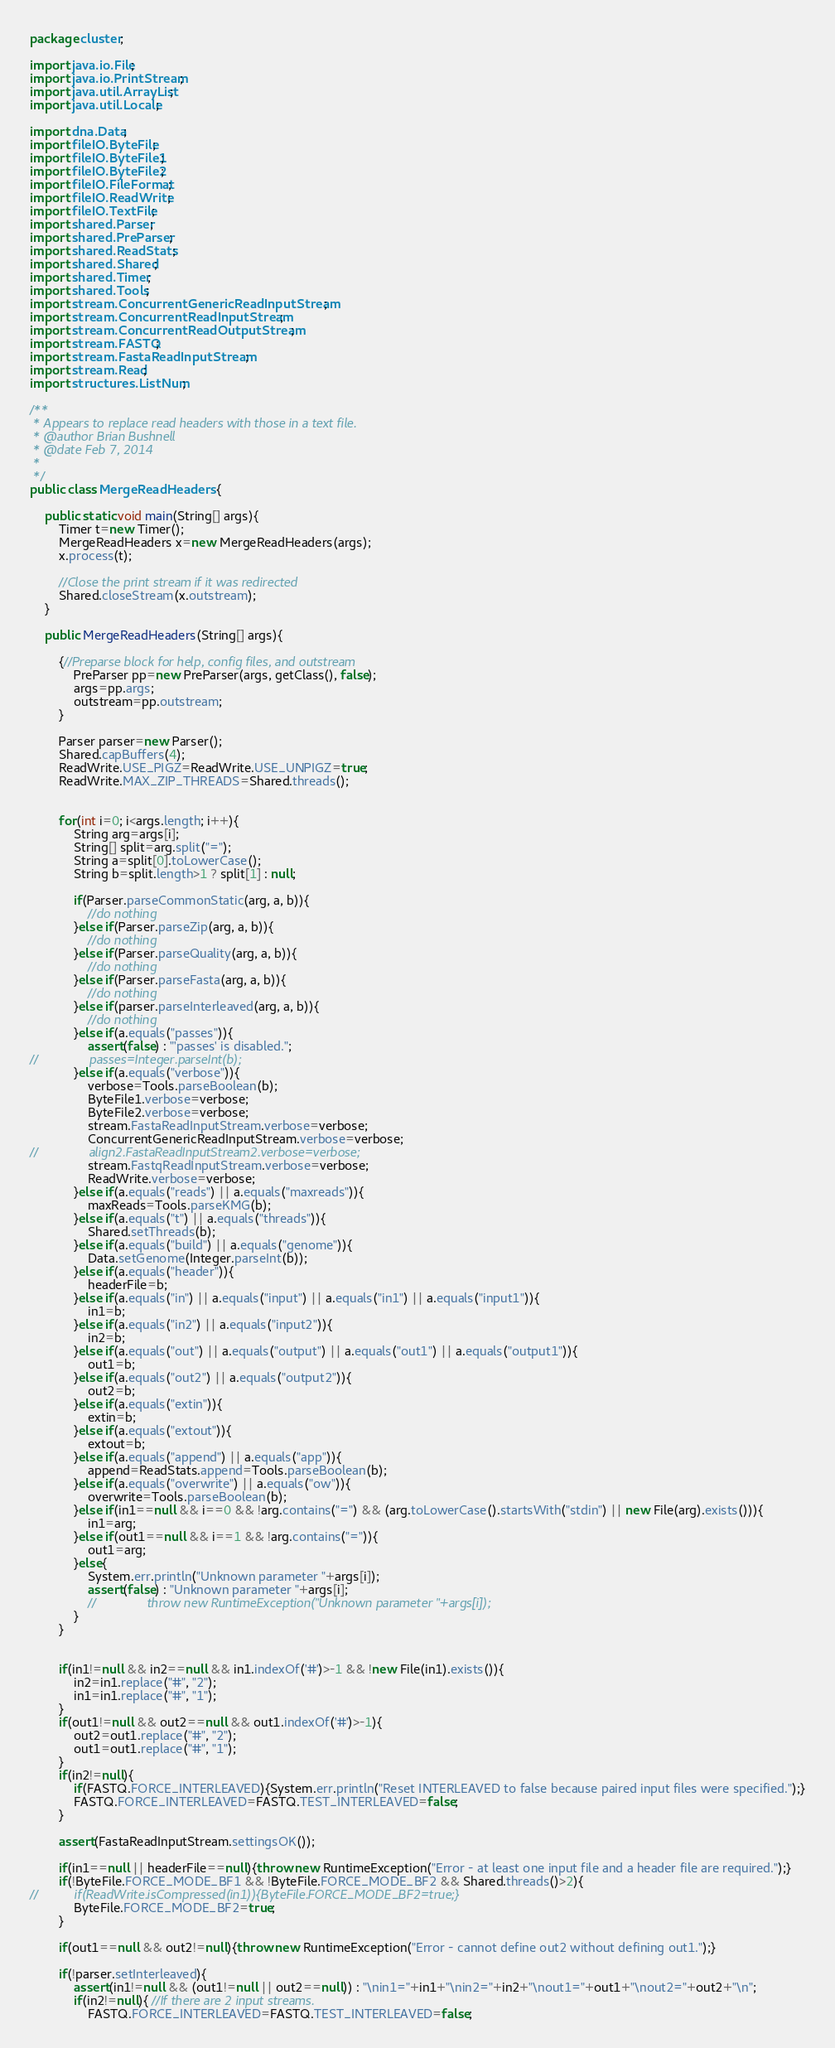<code> <loc_0><loc_0><loc_500><loc_500><_Java_>package cluster;

import java.io.File;
import java.io.PrintStream;
import java.util.ArrayList;
import java.util.Locale;

import dna.Data;
import fileIO.ByteFile;
import fileIO.ByteFile1;
import fileIO.ByteFile2;
import fileIO.FileFormat;
import fileIO.ReadWrite;
import fileIO.TextFile;
import shared.Parser;
import shared.PreParser;
import shared.ReadStats;
import shared.Shared;
import shared.Timer;
import shared.Tools;
import stream.ConcurrentGenericReadInputStream;
import stream.ConcurrentReadInputStream;
import stream.ConcurrentReadOutputStream;
import stream.FASTQ;
import stream.FastaReadInputStream;
import stream.Read;
import structures.ListNum;

/**
 * Appears to replace read headers with those in a text file.
 * @author Brian Bushnell
 * @date Feb 7, 2014
 *
 */
public class MergeReadHeaders {
	
	public static void main(String[] args){
		Timer t=new Timer();
		MergeReadHeaders x=new MergeReadHeaders(args);
		x.process(t);
		
		//Close the print stream if it was redirected
		Shared.closeStream(x.outstream);
	}
	
	public MergeReadHeaders(String[] args){
		
		{//Preparse block for help, config files, and outstream
			PreParser pp=new PreParser(args, getClass(), false);
			args=pp.args;
			outstream=pp.outstream;
		}
		
		Parser parser=new Parser();
		Shared.capBuffers(4);
		ReadWrite.USE_PIGZ=ReadWrite.USE_UNPIGZ=true;
		ReadWrite.MAX_ZIP_THREADS=Shared.threads();
		
		
		for(int i=0; i<args.length; i++){
			String arg=args[i];
			String[] split=arg.split("=");
			String a=split[0].toLowerCase();
			String b=split.length>1 ? split[1] : null;
			
			if(Parser.parseCommonStatic(arg, a, b)){
				//do nothing
			}else if(Parser.parseZip(arg, a, b)){
				//do nothing
			}else if(Parser.parseQuality(arg, a, b)){
				//do nothing
			}else if(Parser.parseFasta(arg, a, b)){
				//do nothing
			}else if(parser.parseInterleaved(arg, a, b)){
				//do nothing
			}else if(a.equals("passes")){
				assert(false) : "'passes' is disabled.";
//				passes=Integer.parseInt(b);
			}else if(a.equals("verbose")){
				verbose=Tools.parseBoolean(b);
				ByteFile1.verbose=verbose;
				ByteFile2.verbose=verbose;
				stream.FastaReadInputStream.verbose=verbose;
				ConcurrentGenericReadInputStream.verbose=verbose;
//				align2.FastaReadInputStream2.verbose=verbose;
				stream.FastqReadInputStream.verbose=verbose;
				ReadWrite.verbose=verbose;
			}else if(a.equals("reads") || a.equals("maxreads")){
				maxReads=Tools.parseKMG(b);
			}else if(a.equals("t") || a.equals("threads")){
				Shared.setThreads(b);
			}else if(a.equals("build") || a.equals("genome")){
				Data.setGenome(Integer.parseInt(b));
			}else if(a.equals("header")){
				headerFile=b;
			}else if(a.equals("in") || a.equals("input") || a.equals("in1") || a.equals("input1")){
				in1=b;
			}else if(a.equals("in2") || a.equals("input2")){
				in2=b;
			}else if(a.equals("out") || a.equals("output") || a.equals("out1") || a.equals("output1")){
				out1=b;
			}else if(a.equals("out2") || a.equals("output2")){
				out2=b;
			}else if(a.equals("extin")){
				extin=b;
			}else if(a.equals("extout")){
				extout=b;
			}else if(a.equals("append") || a.equals("app")){
				append=ReadStats.append=Tools.parseBoolean(b);
			}else if(a.equals("overwrite") || a.equals("ow")){
				overwrite=Tools.parseBoolean(b);
			}else if(in1==null && i==0 && !arg.contains("=") && (arg.toLowerCase().startsWith("stdin") || new File(arg).exists())){
				in1=arg;
			}else if(out1==null && i==1 && !arg.contains("=")){
				out1=arg;
			}else{
				System.err.println("Unknown parameter "+args[i]);
				assert(false) : "Unknown parameter "+args[i];
				//				throw new RuntimeException("Unknown parameter "+args[i]);
			}
		}
		
		
		if(in1!=null && in2==null && in1.indexOf('#')>-1 && !new File(in1).exists()){
			in2=in1.replace("#", "2");
			in1=in1.replace("#", "1");
		}
		if(out1!=null && out2==null && out1.indexOf('#')>-1){
			out2=out1.replace("#", "2");
			out1=out1.replace("#", "1");
		}
		if(in2!=null){
			if(FASTQ.FORCE_INTERLEAVED){System.err.println("Reset INTERLEAVED to false because paired input files were specified.");}
			FASTQ.FORCE_INTERLEAVED=FASTQ.TEST_INTERLEAVED=false;
		}
		
		assert(FastaReadInputStream.settingsOK());
		
		if(in1==null || headerFile==null){throw new RuntimeException("Error - at least one input file and a header file are required.");}
		if(!ByteFile.FORCE_MODE_BF1 && !ByteFile.FORCE_MODE_BF2 && Shared.threads()>2){
//			if(ReadWrite.isCompressed(in1)){ByteFile.FORCE_MODE_BF2=true;}
			ByteFile.FORCE_MODE_BF2=true;
		}
		
		if(out1==null && out2!=null){throw new RuntimeException("Error - cannot define out2 without defining out1.");}
		
		if(!parser.setInterleaved){
			assert(in1!=null && (out1!=null || out2==null)) : "\nin1="+in1+"\nin2="+in2+"\nout1="+out1+"\nout2="+out2+"\n";
			if(in2!=null){ //If there are 2 input streams.
				FASTQ.FORCE_INTERLEAVED=FASTQ.TEST_INTERLEAVED=false;</code> 